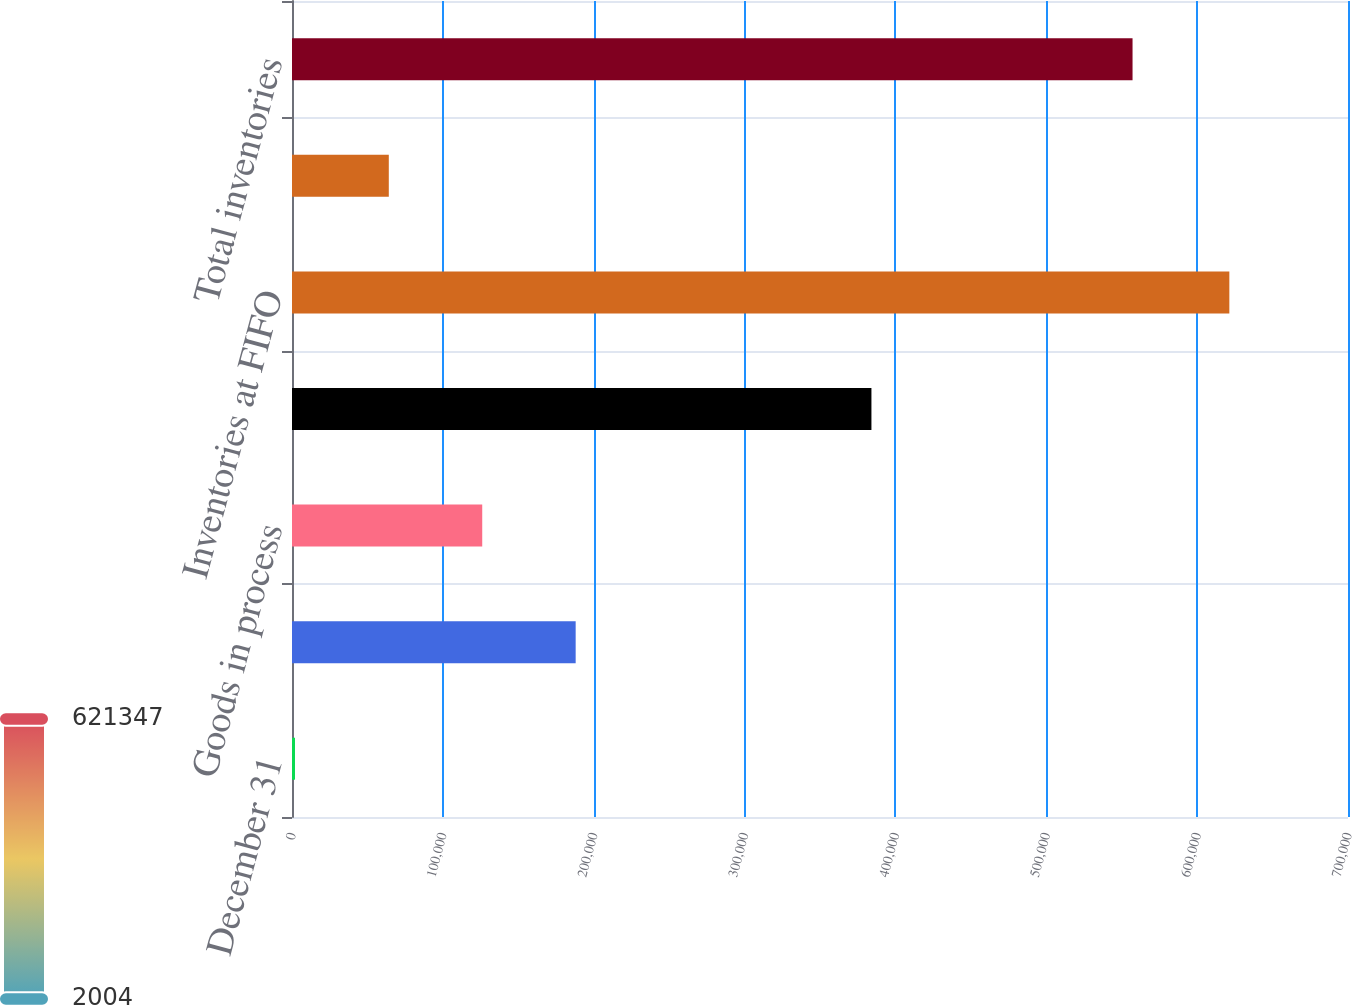<chart> <loc_0><loc_0><loc_500><loc_500><bar_chart><fcel>December 31<fcel>Raw materials<fcel>Goods in process<fcel>Finished goods<fcel>Inventories at FIFO<fcel>Adjustment to LIFO<fcel>Total inventories<nl><fcel>2004<fcel>188036<fcel>126101<fcel>384094<fcel>621347<fcel>64167<fcel>557180<nl></chart> 